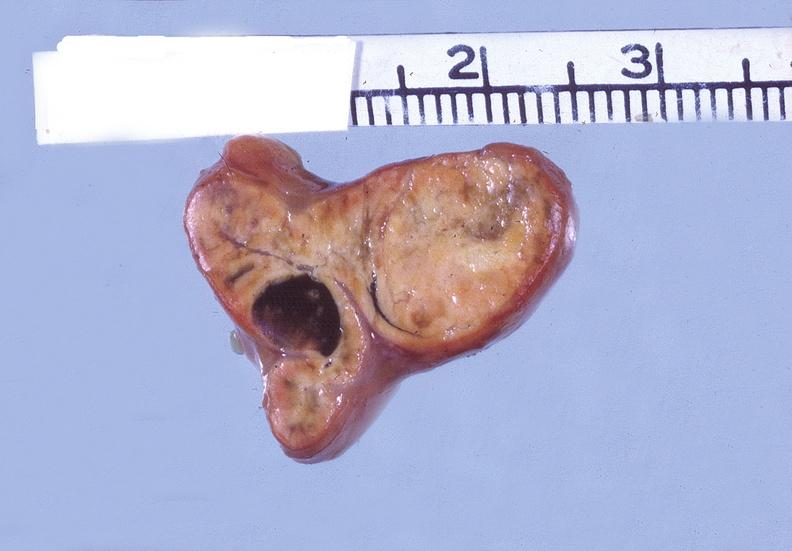what is present?
Answer the question using a single word or phrase. Endocrine 